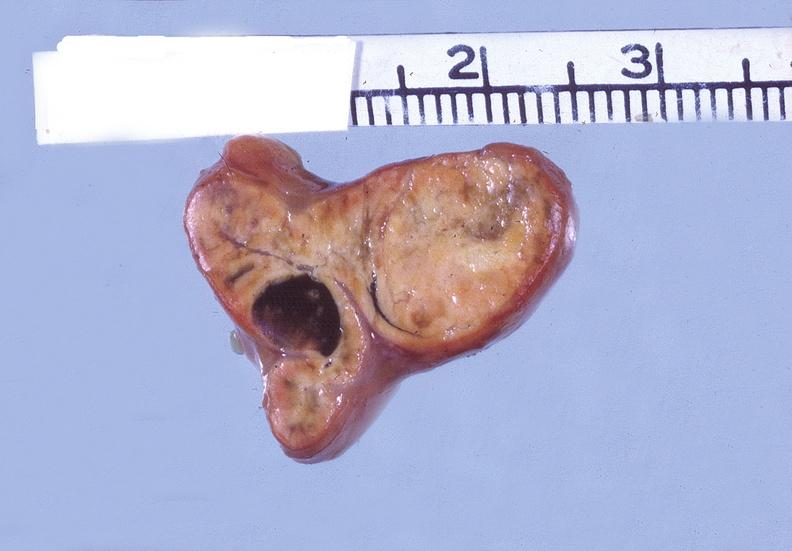what is present?
Answer the question using a single word or phrase. Endocrine 